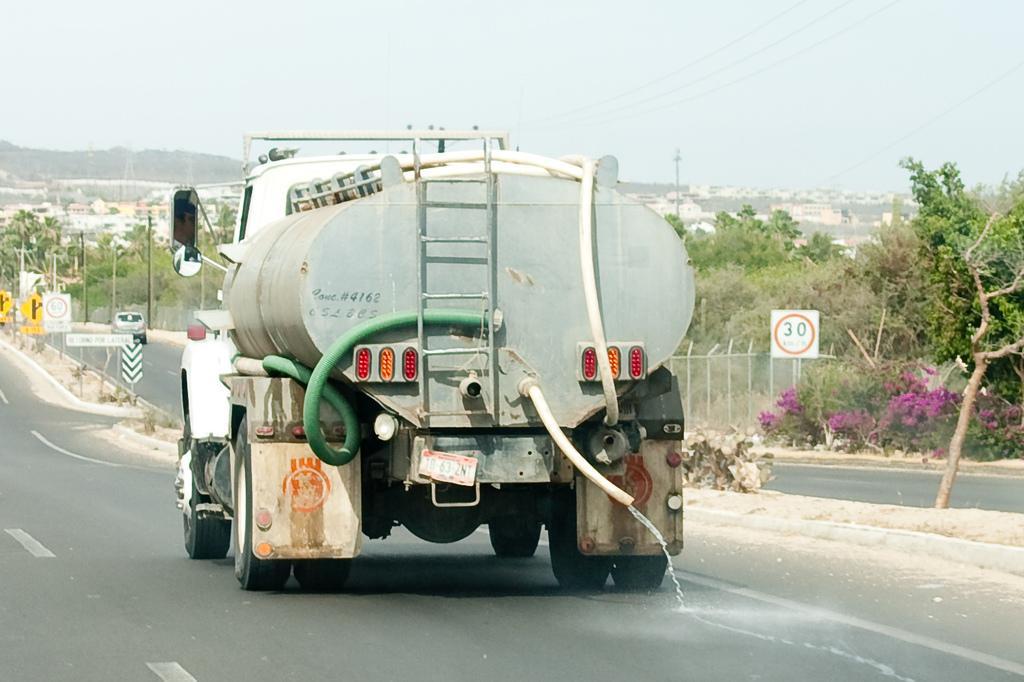Please provide a concise description of this image. In this image we can see a vehicle on the road. In the background, we can see fence, plants, flowers, trees, poles, sign boards and buildings. At the top of the image, we can see the sky and wires. 